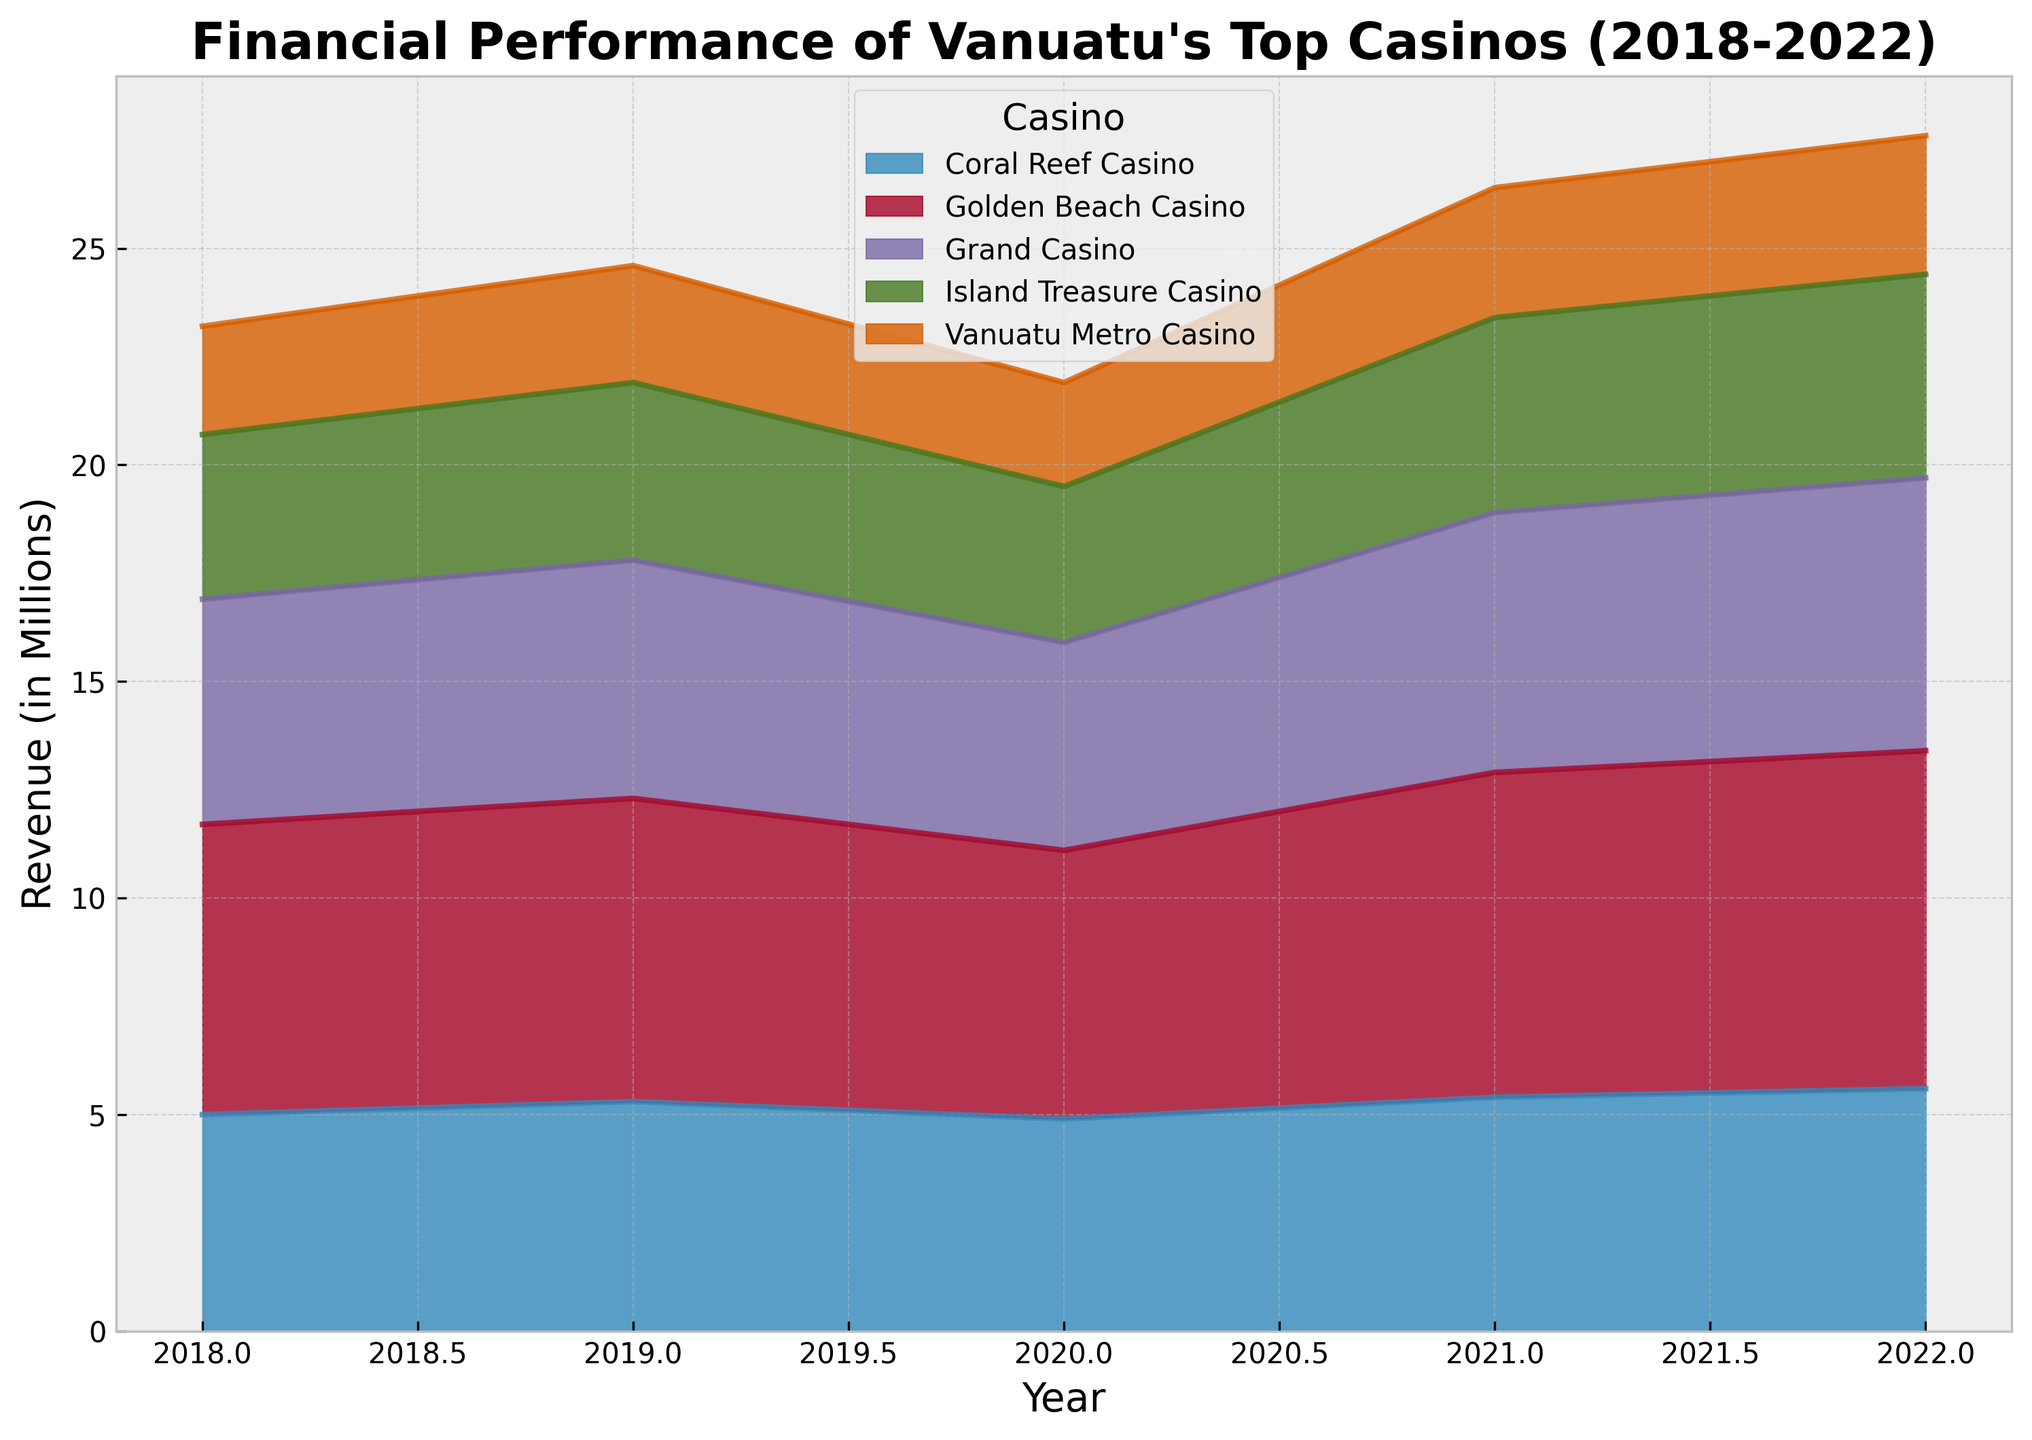Which casino had the highest revenue in 2022? Looking at the highest point in the area chart for 2022, we can see that the Golden Beach Casino reaches the highest revenue.
Answer: Golden Beach Casino Between 2018 and 2022, which casino showed the greatest increase in revenue? Subtract the revenue of each casino in 2018 from their respective revenue in 2022, and find the maximum difference. Golden Beach Casino increased from 6.7 to 7.8, an increase of 1.1 million.
Answer: Golden Beach Casino Which year did Grand Casino experience the lowest revenue? By locating the lowest point in Grand Casino's area along the x-axis, we find that in 2020 the revenue was the lowest at 4.8 million.
Answer: 2020 How much total revenue did Island Treasure Casino make from 2018 to 2022? Sum the revenues for Island Treasure Casino from each year: 3.8 + 4.1 + 3.6 + 4.5 + 4.7 = 20.7 million.
Answer: 20.7 million Compare the revenue of Coral Reef Casino and Grand Casino in 2021. Which was higher? Look at the values for both casinos in 2021: Coral Reef Casino (5.4 million) and Grand Casino (6.0 million). Grand Casino had higher revenue.
Answer: Grand Casino In which year was the total combined revenue of all casinos the highest? Sum the revenues of all casinos for each year and compare: 
- 2018: 23.2 
- 2019: 24.6 
- 2020: 21.9 
- 2021: 26.4 
- 2022: 27.6 
The highest total revenue was in 2022.
Answer: 2022 By how much did the revenue of Vanuatu Metro Casino increase from 2020 to 2022? Subtract the 2020 revenue from the 2022 revenue: 3.2 - 2.4 = 0.8 million.
Answer: 0.8 million How does the trend of Golden Beach Casino from 2018 to 2022 compare with the trend of Island Treasure Casino? Golden Beach Casino shows a consistent upward trend each year, whereas Island Treasure Casino has fluctuating revenues but generally increasing.
Answer: Consistent upward vs Fluctuating upward Which casino had the greatest fluctuation in revenue from year to year? By observing the peaks and troughs in the area chart, we notice Golden Beach Casino has noticeable fluctuations compared to its initial value.
Answer: Golden Beach Casino 